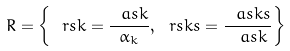<formula> <loc_0><loc_0><loc_500><loc_500>R = \left \{ \ r s k = \frac { \ a s k } { \alpha _ { k } } , \ r s k s = \frac { \ a s k s } { \ a s k } \right \}</formula> 